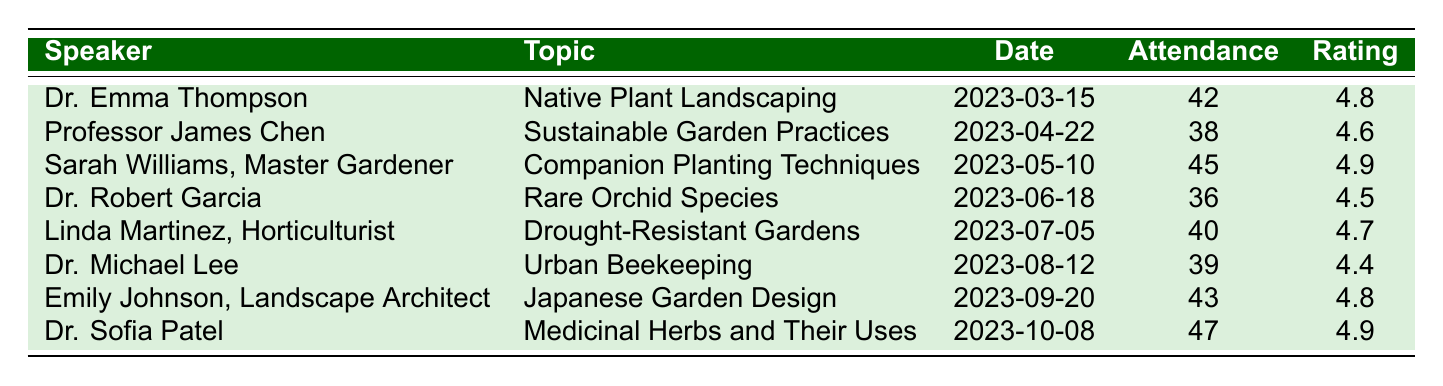What was the topic of Dr. Emma Thompson's talk? According to the table, Dr. Emma Thompson spoke about "Native Plant Landscaping."
Answer: Native Plant Landscaping How many members attended the session on Sustainable Garden Practices? The table indicates that 38 members attended the session presented by Professor James Chen on "Sustainable Garden Practices."
Answer: 38 Who received the highest Member Satisfaction Rating? By comparing the Member Satisfaction Ratings, Sarah Williams and Dr. Sofia Patel both received a rating of 4.9, which is the highest among all speakers.
Answer: Sarah Williams and Dr. Sofia Patel What is the average Member Satisfaction Rating of all speakers? To find the average, we sum the ratings: (4.8 + 4.6 + 4.9 + 4.5 + 4.7 + 4.4 + 4.8 + 4.9) = 36.6. There are 8 ratings, so we divide by 8, giving us an average of 36.6 / 8 = 4.575.
Answer: 4.575 Did Linda Martinez, the horticulturist, have a higher or lower attendance than Dr. Robert Garcia? Linda Martinez had 40 attendees, while Dr. Robert Garcia had 36. Since 40 is greater than 36, Linda had higher attendance.
Answer: Higher What was the Member Satisfaction Rating for the least attended session? The session with the least attendance was Dr. Robert Garcia's with 36 attendees, which had a Member Satisfaction Rating of 4.5.
Answer: 4.5 How many total attendees were there across all sessions? To find the total, we sum all the attendance values: (42 + 38 + 45 + 36 + 40 + 39 + 43 + 47) = 390.
Answer: 390 Identify the speaker who presented on "Japanese Garden Design." Referring to the table, Emily Johnson, a Landscape Architect, presented on "Japanese Garden Design."
Answer: Emily Johnson Which speaker had a satisfaction rating below 4.5? The table shows Dr. Michael Lee with a satisfaction rating of 4.4, which is below 4.5.
Answer: Dr. Michael Lee Was the average attendance greater than 40 members? The total attendance is 390 over 8 events, giving an average of 390 / 8 = 48.75, which is greater than 40.
Answer: Yes 